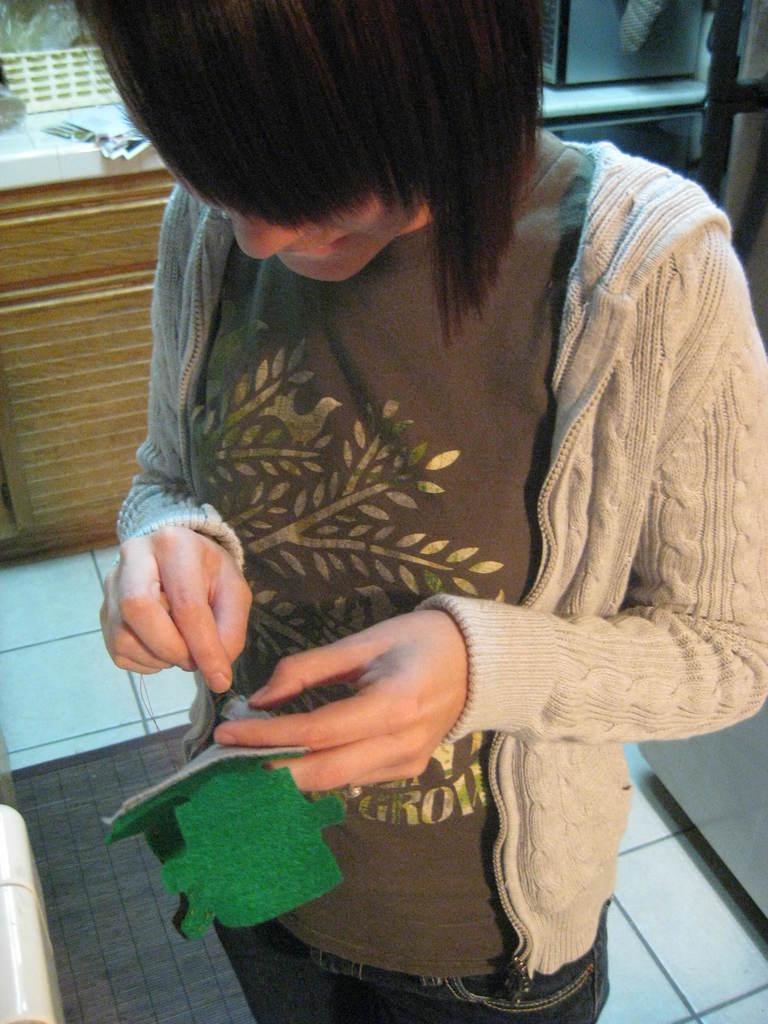Could you give a brief overview of what you see in this image? In this picture I can see a woman holding a cloth in her hand and I can see a door mat on the floor and I can see papers and a basket on the counter top. 